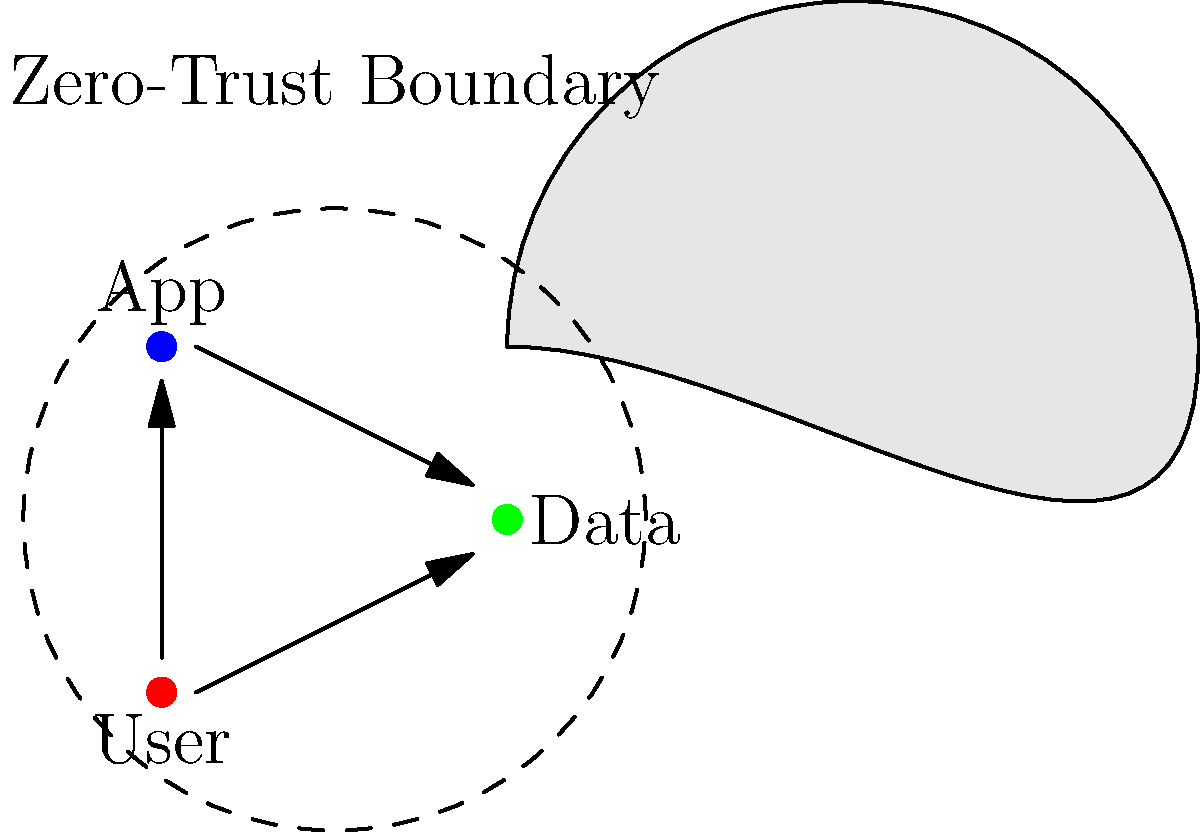In implementing a zero-trust architecture for a cloud-based network environment, which critical component ensures that all access requests are continuously verified, even from within the network perimeter? To understand the implementation of a zero-trust architecture in a cloud-based network environment, let's break down the key components and principles:

1. Continuous Verification: In a zero-trust model, every access request is treated as if it originates from an untrusted network. This means that even requests from within the traditional network perimeter are not automatically trusted.

2. Least Privilege Access: Users and systems are granted the minimum permissions necessary to perform their tasks, reducing the potential impact of a breach.

3. Micro-segmentation: The network is divided into small, isolated segments to contain potential breaches and limit lateral movement.

4. Identity-based Access: Access is granted based on the identity of the user or device, rather than their network location.

5. Device Health: The security posture of the device making the request is considered before granting access.

6. Data Protection: Data is encrypted both in transit and at rest, and access to data is tightly controlled.

7. Continuous Monitoring: All network traffic and access requests are logged and analyzed for anomalies.

The critical component that ties all these principles together and ensures that all access requests are continuously verified is the Policy Enforcement Point (PEP). The PEP acts as a central authority that:

- Intercepts all access requests
- Verifies the identity of the requester
- Checks the health and compliance of the device
- Evaluates the request against security policies
- Grants or denies access based on the evaluation

This component is crucial because it enforces the "never trust, always verify" principle of zero-trust architecture, regardless of where the request originates from within the cloud environment.
Answer: Policy Enforcement Point (PEP) 